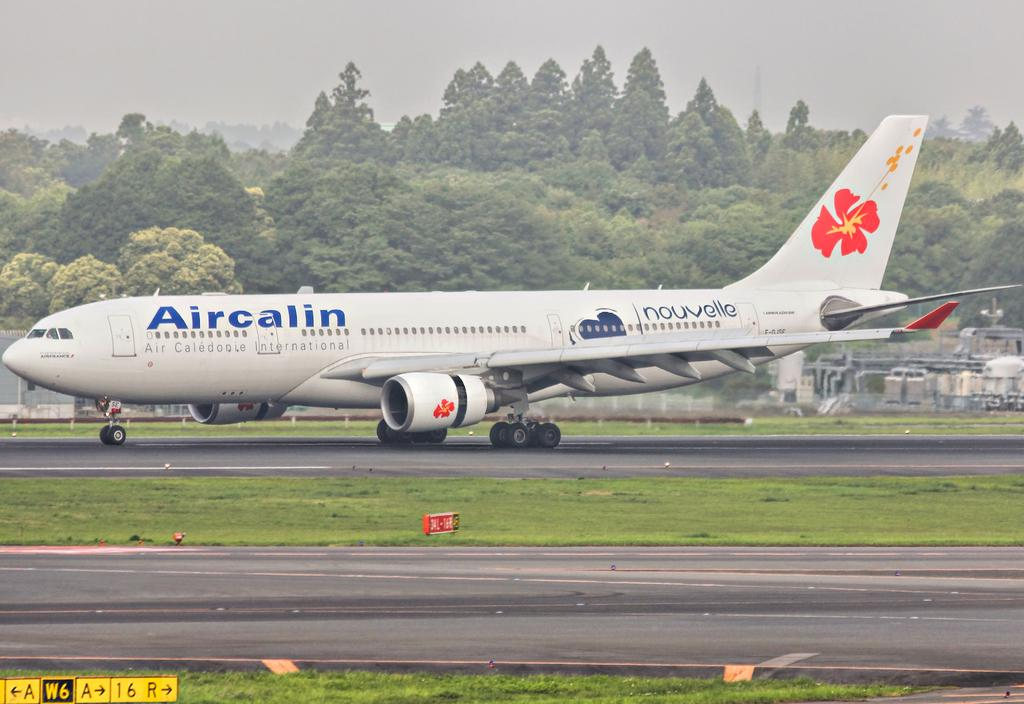<image>
Share a concise interpretation of the image provided. An Aircalin airplane has a bright orange flower on the tail. 